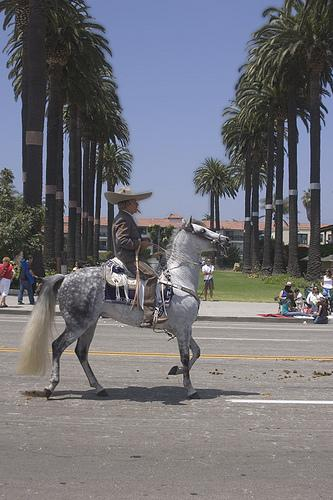Describe the person riding the horse. A man in a white shirt and shorts is riding the horse. He is wearing a big hat, possibly a sombrero, and is an older man with light skin. What type of trees are seen in the image, and how many are visible? A row of six palm trees is visible with their branches and the sky in the background. Mention the details about the road, including its markings and condition. The road is tarmacked with white and yellow lines painted on it. There is a white strip in the middle, and there are horse poop scattered along the road. What ongoing event is mentioned in the image, and who are the spectators? A parade is taking place with people and a horse in the scene. Spectators are watching the parade along the road area. Describe the appearance of the shoe mentioned in the image. The shoe is brown in color and appears to belong to a rider, as the horse has a saddle, stirrups, and reigns. Describe the objects in the sky and their appearance. The sky is blue in color, and palm tree branches can also be seen. What are the main colors of items mentioned in the image, including animals, clothing, and objects? The horse is white, the hat is unspecified, the road is tarmacked, the shoe is brown, the man is light skinned, the leaves are green, and the roof is red. State the color and appearance of the hat worn by the man riding the horse. The hat has a large brim and is likely a sombrero worn by an older man. The color is not specified. Mention the clothing and appearance of the other people in the image. There is a person with long hair sitting on a red blanket, a man in a white shirt and shorts, a person with a red shirt and white pants, and spectators watching a parade. What is the main animal seen in the image and describe its appearance? The main animal is a dappled gray horse with a long fluffy tail, prancing and lifting the hoof. The horse is wearing a saddle, stirrups, and reigns. 